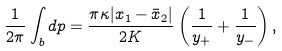<formula> <loc_0><loc_0><loc_500><loc_500>\frac { 1 } { 2 \pi } \int _ { b } d p = \frac { \pi \kappa | x _ { 1 } - \bar { x } _ { 2 } | } { 2 K } \left ( \frac { 1 } { y _ { + } } + \frac { 1 } { y _ { - } } \right ) ,</formula> 